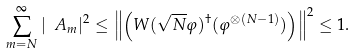<formula> <loc_0><loc_0><loc_500><loc_500>\sum _ { m = N } ^ { \infty } | \ A _ { m } | ^ { 2 } \leq \left \| \left ( W ( \sqrt { N } \varphi ) ^ { \dag } ( \varphi ^ { \otimes ( N - 1 ) } ) \right ) \right \| ^ { 2 } \leq 1 .</formula> 